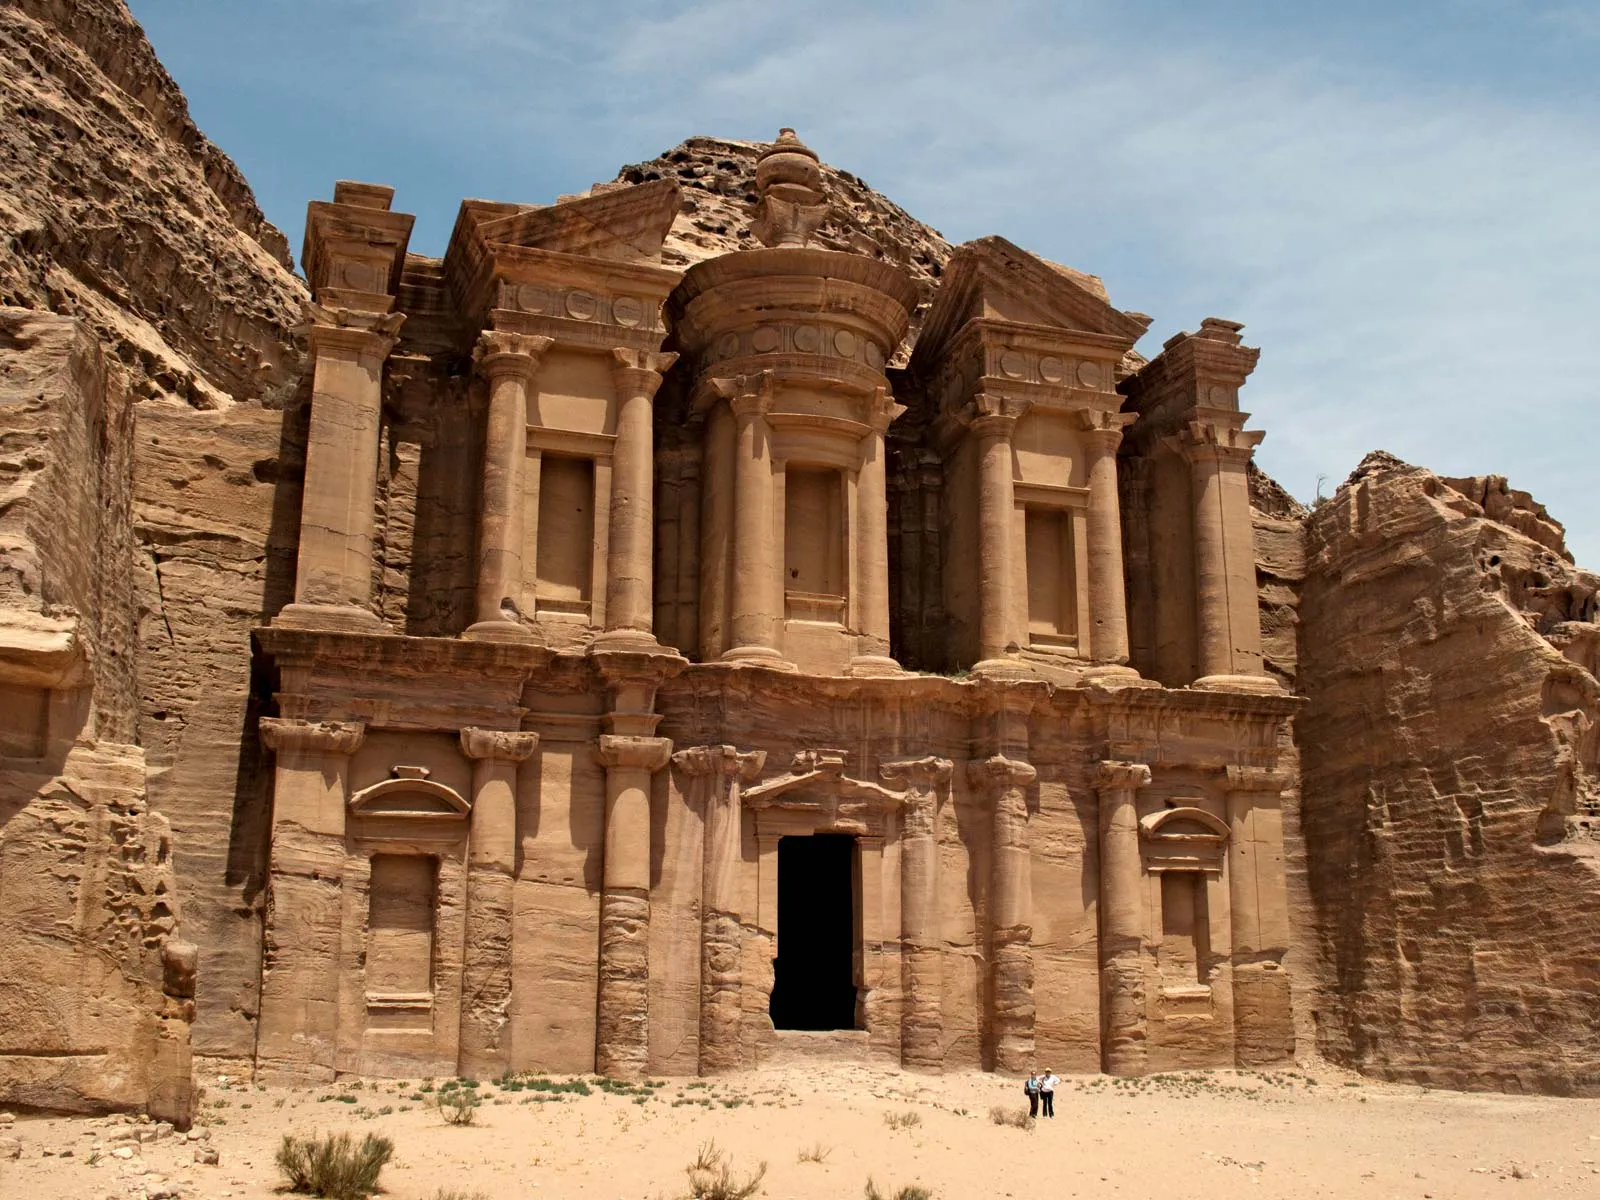How would you describe the surroundings and environment of this monument? The environment surrounding the Monastery is characterized by rugged sandstone cliffs, vast open spaces, and a serene desert landscape. The sandy ground stretches out in front of the Monastery, with sparse vegetation dotting the barren terrain. The warm, golden hues of the stone harmonize with the desert surroundings, creating a picturesque scene that feels both timeless and majestic. The expansive blue sky overhead adds to the tranquility and grandeur of the setting, offering a stark yet complementary contrast to the earthy tones below. This natural harmony not only accentuates the architectural beauty of the Monastery but also evokes a profound sense of historical and cultural significance. Imagine describing this scene in a poetic manner. In the heart of the ancient dunes where the whispering winds of time reside, stands a testament of human grandeur, the Monastery of Petra carved in stone. The golden sandstone, kissed by the desert sun, tells tales in every grain of sand. Beneath the cerulean expanse, this majestic relic of yore breathes the echoes of an illustrious past. Between the ceaseless skies and the enduring earth, the Monastery rises, its facade a symphony of shadows and light. The solitary figures below are but whispers to its colossal roars, pilgrims in the sands of time, dwarfed by the eternal.  If the Monastery could talk, what stories do you think it would tell? Ah, if the Monastery could speak, it would weave tales of an ancient civilization that thrived in the harsh desert. It would tell stories of the Nabateans, who mastered the art of carving life into stone, creating not just grand monuments but also intricate water systems that sustained their city. It would recount the rhythms of daily life, the clamor of the marketplace, the solemnity of religious ceremonies, and the echoes of its grandeur reverberating through the ages. It would speak of the watchfulness of its builders, the strategic importance of Petra, and the diverse cultures that came and went, leaving their whispers in its sandstone walls. And it would whisper of the quiet nights under a canopy of stars, standing sentinel as centuries turned. Based on the image, what might a day in the life of an ancient Nabatean look like? A day in the life of an ancient Nabatean in Petra would start with the soft light of dawn breaking over the cliffs, casting a golden hue over the sandstone city. Early in the morning, the city's inhabitants would bustle in the shadow of the grand monuments like the Monastery, their daily activities echoing through the narrow canyons. Traders would prepare their goods, merchants open their stalls, and craftsmen set to work. The air would be filled with the clamor of people and animals, the scent of spices, and the sound of negotiations. As the sun climbed higher, casting a harsh light on the city, people would seek shade and water from the ingeniously constructed cisterns and channels. Priests might perform ceremonies in the temples while scholars discuss trade, politics, and distant lands. As evening approached, the city's pace would slow. Families would gather in their homes, sharing meals and stories, while others would find solace in the quiet majesty of the night, under the starlit sky. The grand structures like the Monastery would stand as silent witnesses to the cadence of daily life, embodying the spirit and resilience of the Nabatean people. 